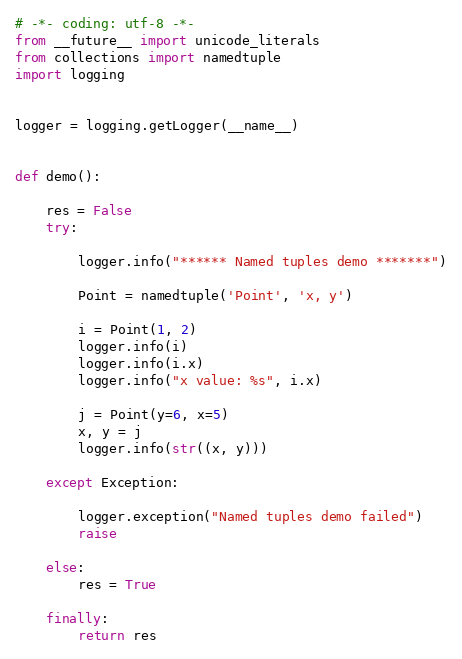<code> <loc_0><loc_0><loc_500><loc_500><_Python_># -*- coding: utf-8 -*-
from __future__ import unicode_literals
from collections import namedtuple
import logging


logger = logging.getLogger(__name__)


def demo():

    res = False
    try:

        logger.info("****** Named tuples demo *******")

        Point = namedtuple('Point', 'x, y')

        i = Point(1, 2)
        logger.info(i)
        logger.info(i.x)
        logger.info("x value: %s", i.x)

        j = Point(y=6, x=5)
        x, y = j
        logger.info(str((x, y)))

    except Exception:

        logger.exception("Named tuples demo failed")
        raise

    else:
        res = True

    finally:
        return res
</code> 